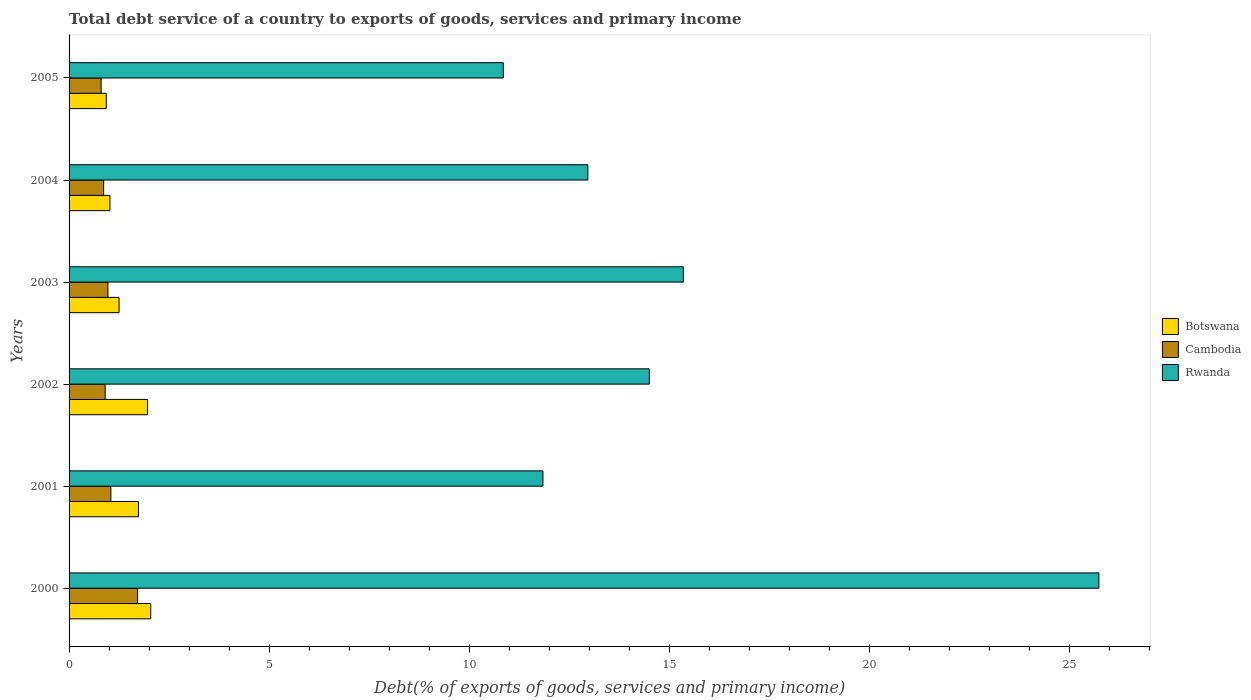How many different coloured bars are there?
Make the answer very short. 3. How many bars are there on the 2nd tick from the top?
Your response must be concise. 3. How many bars are there on the 2nd tick from the bottom?
Give a very brief answer. 3. What is the label of the 2nd group of bars from the top?
Provide a short and direct response. 2004. In how many cases, is the number of bars for a given year not equal to the number of legend labels?
Provide a succinct answer. 0. What is the total debt service in Botswana in 2003?
Ensure brevity in your answer.  1.25. Across all years, what is the maximum total debt service in Rwanda?
Provide a short and direct response. 25.73. Across all years, what is the minimum total debt service in Botswana?
Keep it short and to the point. 0.93. What is the total total debt service in Rwanda in the graph?
Your answer should be very brief. 91.22. What is the difference between the total debt service in Rwanda in 2004 and that in 2005?
Your answer should be very brief. 2.11. What is the difference between the total debt service in Rwanda in 2004 and the total debt service in Botswana in 2001?
Make the answer very short. 11.23. What is the average total debt service in Rwanda per year?
Make the answer very short. 15.2. In the year 2002, what is the difference between the total debt service in Cambodia and total debt service in Botswana?
Provide a succinct answer. -1.06. What is the ratio of the total debt service in Cambodia in 2002 to that in 2005?
Give a very brief answer. 1.13. Is the total debt service in Cambodia in 2003 less than that in 2004?
Your answer should be very brief. No. Is the difference between the total debt service in Cambodia in 2000 and 2002 greater than the difference between the total debt service in Botswana in 2000 and 2002?
Provide a short and direct response. Yes. What is the difference between the highest and the second highest total debt service in Rwanda?
Your answer should be compact. 10.38. What is the difference between the highest and the lowest total debt service in Rwanda?
Your response must be concise. 14.88. What does the 2nd bar from the top in 2005 represents?
Make the answer very short. Cambodia. What does the 3rd bar from the bottom in 2004 represents?
Provide a short and direct response. Rwanda. Are the values on the major ticks of X-axis written in scientific E-notation?
Offer a very short reply. No. Does the graph contain any zero values?
Keep it short and to the point. No. Where does the legend appear in the graph?
Ensure brevity in your answer.  Center right. How are the legend labels stacked?
Provide a short and direct response. Vertical. What is the title of the graph?
Keep it short and to the point. Total debt service of a country to exports of goods, services and primary income. Does "Botswana" appear as one of the legend labels in the graph?
Your answer should be compact. Yes. What is the label or title of the X-axis?
Your answer should be very brief. Debt(% of exports of goods, services and primary income). What is the Debt(% of exports of goods, services and primary income) in Botswana in 2000?
Ensure brevity in your answer.  2.04. What is the Debt(% of exports of goods, services and primary income) in Cambodia in 2000?
Provide a succinct answer. 1.71. What is the Debt(% of exports of goods, services and primary income) of Rwanda in 2000?
Make the answer very short. 25.73. What is the Debt(% of exports of goods, services and primary income) of Botswana in 2001?
Make the answer very short. 1.73. What is the Debt(% of exports of goods, services and primary income) of Cambodia in 2001?
Offer a very short reply. 1.04. What is the Debt(% of exports of goods, services and primary income) of Rwanda in 2001?
Provide a short and direct response. 11.84. What is the Debt(% of exports of goods, services and primary income) of Botswana in 2002?
Your answer should be compact. 1.96. What is the Debt(% of exports of goods, services and primary income) in Cambodia in 2002?
Your answer should be very brief. 0.9. What is the Debt(% of exports of goods, services and primary income) of Rwanda in 2002?
Your answer should be very brief. 14.5. What is the Debt(% of exports of goods, services and primary income) in Botswana in 2003?
Make the answer very short. 1.25. What is the Debt(% of exports of goods, services and primary income) in Cambodia in 2003?
Keep it short and to the point. 0.97. What is the Debt(% of exports of goods, services and primary income) of Rwanda in 2003?
Keep it short and to the point. 15.35. What is the Debt(% of exports of goods, services and primary income) of Botswana in 2004?
Give a very brief answer. 1.02. What is the Debt(% of exports of goods, services and primary income) of Cambodia in 2004?
Keep it short and to the point. 0.86. What is the Debt(% of exports of goods, services and primary income) of Rwanda in 2004?
Your answer should be very brief. 12.96. What is the Debt(% of exports of goods, services and primary income) in Botswana in 2005?
Ensure brevity in your answer.  0.93. What is the Debt(% of exports of goods, services and primary income) in Cambodia in 2005?
Keep it short and to the point. 0.8. What is the Debt(% of exports of goods, services and primary income) in Rwanda in 2005?
Offer a terse response. 10.85. Across all years, what is the maximum Debt(% of exports of goods, services and primary income) in Botswana?
Ensure brevity in your answer.  2.04. Across all years, what is the maximum Debt(% of exports of goods, services and primary income) of Cambodia?
Offer a very short reply. 1.71. Across all years, what is the maximum Debt(% of exports of goods, services and primary income) of Rwanda?
Your answer should be compact. 25.73. Across all years, what is the minimum Debt(% of exports of goods, services and primary income) of Botswana?
Offer a very short reply. 0.93. Across all years, what is the minimum Debt(% of exports of goods, services and primary income) of Cambodia?
Provide a short and direct response. 0.8. Across all years, what is the minimum Debt(% of exports of goods, services and primary income) of Rwanda?
Your response must be concise. 10.85. What is the total Debt(% of exports of goods, services and primary income) in Botswana in the graph?
Your answer should be compact. 8.94. What is the total Debt(% of exports of goods, services and primary income) of Cambodia in the graph?
Provide a succinct answer. 6.29. What is the total Debt(% of exports of goods, services and primary income) of Rwanda in the graph?
Provide a succinct answer. 91.22. What is the difference between the Debt(% of exports of goods, services and primary income) in Botswana in 2000 and that in 2001?
Your answer should be compact. 0.31. What is the difference between the Debt(% of exports of goods, services and primary income) in Cambodia in 2000 and that in 2001?
Make the answer very short. 0.67. What is the difference between the Debt(% of exports of goods, services and primary income) in Rwanda in 2000 and that in 2001?
Your response must be concise. 13.89. What is the difference between the Debt(% of exports of goods, services and primary income) in Botswana in 2000 and that in 2002?
Provide a short and direct response. 0.08. What is the difference between the Debt(% of exports of goods, services and primary income) in Cambodia in 2000 and that in 2002?
Ensure brevity in your answer.  0.81. What is the difference between the Debt(% of exports of goods, services and primary income) of Rwanda in 2000 and that in 2002?
Keep it short and to the point. 11.23. What is the difference between the Debt(% of exports of goods, services and primary income) of Botswana in 2000 and that in 2003?
Give a very brief answer. 0.79. What is the difference between the Debt(% of exports of goods, services and primary income) in Cambodia in 2000 and that in 2003?
Ensure brevity in your answer.  0.74. What is the difference between the Debt(% of exports of goods, services and primary income) of Rwanda in 2000 and that in 2003?
Provide a succinct answer. 10.38. What is the difference between the Debt(% of exports of goods, services and primary income) of Botswana in 2000 and that in 2004?
Give a very brief answer. 1.02. What is the difference between the Debt(% of exports of goods, services and primary income) of Cambodia in 2000 and that in 2004?
Your response must be concise. 0.85. What is the difference between the Debt(% of exports of goods, services and primary income) in Rwanda in 2000 and that in 2004?
Ensure brevity in your answer.  12.77. What is the difference between the Debt(% of exports of goods, services and primary income) of Botswana in 2000 and that in 2005?
Ensure brevity in your answer.  1.11. What is the difference between the Debt(% of exports of goods, services and primary income) of Cambodia in 2000 and that in 2005?
Offer a very short reply. 0.91. What is the difference between the Debt(% of exports of goods, services and primary income) of Rwanda in 2000 and that in 2005?
Make the answer very short. 14.88. What is the difference between the Debt(% of exports of goods, services and primary income) in Botswana in 2001 and that in 2002?
Provide a succinct answer. -0.23. What is the difference between the Debt(% of exports of goods, services and primary income) of Cambodia in 2001 and that in 2002?
Your answer should be very brief. 0.14. What is the difference between the Debt(% of exports of goods, services and primary income) of Rwanda in 2001 and that in 2002?
Ensure brevity in your answer.  -2.66. What is the difference between the Debt(% of exports of goods, services and primary income) of Botswana in 2001 and that in 2003?
Provide a succinct answer. 0.48. What is the difference between the Debt(% of exports of goods, services and primary income) of Cambodia in 2001 and that in 2003?
Provide a succinct answer. 0.07. What is the difference between the Debt(% of exports of goods, services and primary income) in Rwanda in 2001 and that in 2003?
Make the answer very short. -3.51. What is the difference between the Debt(% of exports of goods, services and primary income) of Botswana in 2001 and that in 2004?
Provide a short and direct response. 0.71. What is the difference between the Debt(% of exports of goods, services and primary income) of Cambodia in 2001 and that in 2004?
Provide a short and direct response. 0.18. What is the difference between the Debt(% of exports of goods, services and primary income) of Rwanda in 2001 and that in 2004?
Give a very brief answer. -1.12. What is the difference between the Debt(% of exports of goods, services and primary income) in Botswana in 2001 and that in 2005?
Offer a very short reply. 0.8. What is the difference between the Debt(% of exports of goods, services and primary income) in Cambodia in 2001 and that in 2005?
Offer a terse response. 0.24. What is the difference between the Debt(% of exports of goods, services and primary income) of Botswana in 2002 and that in 2003?
Offer a terse response. 0.71. What is the difference between the Debt(% of exports of goods, services and primary income) in Cambodia in 2002 and that in 2003?
Offer a very short reply. -0.07. What is the difference between the Debt(% of exports of goods, services and primary income) in Rwanda in 2002 and that in 2003?
Offer a very short reply. -0.85. What is the difference between the Debt(% of exports of goods, services and primary income) of Botswana in 2002 and that in 2004?
Provide a short and direct response. 0.94. What is the difference between the Debt(% of exports of goods, services and primary income) in Cambodia in 2002 and that in 2004?
Your answer should be compact. 0.04. What is the difference between the Debt(% of exports of goods, services and primary income) in Rwanda in 2002 and that in 2004?
Provide a succinct answer. 1.54. What is the difference between the Debt(% of exports of goods, services and primary income) in Botswana in 2002 and that in 2005?
Provide a short and direct response. 1.03. What is the difference between the Debt(% of exports of goods, services and primary income) in Cambodia in 2002 and that in 2005?
Offer a very short reply. 0.1. What is the difference between the Debt(% of exports of goods, services and primary income) in Rwanda in 2002 and that in 2005?
Offer a terse response. 3.65. What is the difference between the Debt(% of exports of goods, services and primary income) of Botswana in 2003 and that in 2004?
Provide a succinct answer. 0.23. What is the difference between the Debt(% of exports of goods, services and primary income) of Cambodia in 2003 and that in 2004?
Provide a short and direct response. 0.11. What is the difference between the Debt(% of exports of goods, services and primary income) of Rwanda in 2003 and that in 2004?
Your answer should be very brief. 2.38. What is the difference between the Debt(% of exports of goods, services and primary income) of Botswana in 2003 and that in 2005?
Make the answer very short. 0.32. What is the difference between the Debt(% of exports of goods, services and primary income) in Cambodia in 2003 and that in 2005?
Your response must be concise. 0.17. What is the difference between the Debt(% of exports of goods, services and primary income) of Rwanda in 2003 and that in 2005?
Your answer should be compact. 4.5. What is the difference between the Debt(% of exports of goods, services and primary income) of Botswana in 2004 and that in 2005?
Your answer should be compact. 0.09. What is the difference between the Debt(% of exports of goods, services and primary income) in Cambodia in 2004 and that in 2005?
Offer a very short reply. 0.06. What is the difference between the Debt(% of exports of goods, services and primary income) of Rwanda in 2004 and that in 2005?
Offer a terse response. 2.11. What is the difference between the Debt(% of exports of goods, services and primary income) in Botswana in 2000 and the Debt(% of exports of goods, services and primary income) in Cambodia in 2001?
Make the answer very short. 1. What is the difference between the Debt(% of exports of goods, services and primary income) in Botswana in 2000 and the Debt(% of exports of goods, services and primary income) in Rwanda in 2001?
Provide a succinct answer. -9.8. What is the difference between the Debt(% of exports of goods, services and primary income) in Cambodia in 2000 and the Debt(% of exports of goods, services and primary income) in Rwanda in 2001?
Your answer should be very brief. -10.13. What is the difference between the Debt(% of exports of goods, services and primary income) in Botswana in 2000 and the Debt(% of exports of goods, services and primary income) in Cambodia in 2002?
Provide a succinct answer. 1.14. What is the difference between the Debt(% of exports of goods, services and primary income) in Botswana in 2000 and the Debt(% of exports of goods, services and primary income) in Rwanda in 2002?
Provide a succinct answer. -12.46. What is the difference between the Debt(% of exports of goods, services and primary income) in Cambodia in 2000 and the Debt(% of exports of goods, services and primary income) in Rwanda in 2002?
Give a very brief answer. -12.79. What is the difference between the Debt(% of exports of goods, services and primary income) of Botswana in 2000 and the Debt(% of exports of goods, services and primary income) of Cambodia in 2003?
Offer a very short reply. 1.07. What is the difference between the Debt(% of exports of goods, services and primary income) in Botswana in 2000 and the Debt(% of exports of goods, services and primary income) in Rwanda in 2003?
Your answer should be compact. -13.31. What is the difference between the Debt(% of exports of goods, services and primary income) in Cambodia in 2000 and the Debt(% of exports of goods, services and primary income) in Rwanda in 2003?
Keep it short and to the point. -13.63. What is the difference between the Debt(% of exports of goods, services and primary income) in Botswana in 2000 and the Debt(% of exports of goods, services and primary income) in Cambodia in 2004?
Make the answer very short. 1.18. What is the difference between the Debt(% of exports of goods, services and primary income) in Botswana in 2000 and the Debt(% of exports of goods, services and primary income) in Rwanda in 2004?
Keep it short and to the point. -10.92. What is the difference between the Debt(% of exports of goods, services and primary income) of Cambodia in 2000 and the Debt(% of exports of goods, services and primary income) of Rwanda in 2004?
Your response must be concise. -11.25. What is the difference between the Debt(% of exports of goods, services and primary income) of Botswana in 2000 and the Debt(% of exports of goods, services and primary income) of Cambodia in 2005?
Your answer should be compact. 1.24. What is the difference between the Debt(% of exports of goods, services and primary income) of Botswana in 2000 and the Debt(% of exports of goods, services and primary income) of Rwanda in 2005?
Offer a very short reply. -8.81. What is the difference between the Debt(% of exports of goods, services and primary income) of Cambodia in 2000 and the Debt(% of exports of goods, services and primary income) of Rwanda in 2005?
Ensure brevity in your answer.  -9.14. What is the difference between the Debt(% of exports of goods, services and primary income) in Botswana in 2001 and the Debt(% of exports of goods, services and primary income) in Cambodia in 2002?
Provide a short and direct response. 0.83. What is the difference between the Debt(% of exports of goods, services and primary income) in Botswana in 2001 and the Debt(% of exports of goods, services and primary income) in Rwanda in 2002?
Your response must be concise. -12.76. What is the difference between the Debt(% of exports of goods, services and primary income) of Cambodia in 2001 and the Debt(% of exports of goods, services and primary income) of Rwanda in 2002?
Your response must be concise. -13.45. What is the difference between the Debt(% of exports of goods, services and primary income) of Botswana in 2001 and the Debt(% of exports of goods, services and primary income) of Cambodia in 2003?
Keep it short and to the point. 0.76. What is the difference between the Debt(% of exports of goods, services and primary income) of Botswana in 2001 and the Debt(% of exports of goods, services and primary income) of Rwanda in 2003?
Provide a succinct answer. -13.61. What is the difference between the Debt(% of exports of goods, services and primary income) in Cambodia in 2001 and the Debt(% of exports of goods, services and primary income) in Rwanda in 2003?
Provide a succinct answer. -14.3. What is the difference between the Debt(% of exports of goods, services and primary income) in Botswana in 2001 and the Debt(% of exports of goods, services and primary income) in Cambodia in 2004?
Make the answer very short. 0.87. What is the difference between the Debt(% of exports of goods, services and primary income) of Botswana in 2001 and the Debt(% of exports of goods, services and primary income) of Rwanda in 2004?
Provide a short and direct response. -11.23. What is the difference between the Debt(% of exports of goods, services and primary income) of Cambodia in 2001 and the Debt(% of exports of goods, services and primary income) of Rwanda in 2004?
Give a very brief answer. -11.92. What is the difference between the Debt(% of exports of goods, services and primary income) of Botswana in 2001 and the Debt(% of exports of goods, services and primary income) of Cambodia in 2005?
Provide a succinct answer. 0.93. What is the difference between the Debt(% of exports of goods, services and primary income) of Botswana in 2001 and the Debt(% of exports of goods, services and primary income) of Rwanda in 2005?
Offer a very short reply. -9.12. What is the difference between the Debt(% of exports of goods, services and primary income) of Cambodia in 2001 and the Debt(% of exports of goods, services and primary income) of Rwanda in 2005?
Your answer should be very brief. -9.8. What is the difference between the Debt(% of exports of goods, services and primary income) in Botswana in 2002 and the Debt(% of exports of goods, services and primary income) in Cambodia in 2003?
Your response must be concise. 0.99. What is the difference between the Debt(% of exports of goods, services and primary income) of Botswana in 2002 and the Debt(% of exports of goods, services and primary income) of Rwanda in 2003?
Offer a terse response. -13.38. What is the difference between the Debt(% of exports of goods, services and primary income) in Cambodia in 2002 and the Debt(% of exports of goods, services and primary income) in Rwanda in 2003?
Your answer should be compact. -14.44. What is the difference between the Debt(% of exports of goods, services and primary income) of Botswana in 2002 and the Debt(% of exports of goods, services and primary income) of Cambodia in 2004?
Your answer should be compact. 1.1. What is the difference between the Debt(% of exports of goods, services and primary income) in Botswana in 2002 and the Debt(% of exports of goods, services and primary income) in Rwanda in 2004?
Your answer should be very brief. -11. What is the difference between the Debt(% of exports of goods, services and primary income) of Cambodia in 2002 and the Debt(% of exports of goods, services and primary income) of Rwanda in 2004?
Offer a terse response. -12.06. What is the difference between the Debt(% of exports of goods, services and primary income) of Botswana in 2002 and the Debt(% of exports of goods, services and primary income) of Cambodia in 2005?
Give a very brief answer. 1.16. What is the difference between the Debt(% of exports of goods, services and primary income) in Botswana in 2002 and the Debt(% of exports of goods, services and primary income) in Rwanda in 2005?
Give a very brief answer. -8.89. What is the difference between the Debt(% of exports of goods, services and primary income) of Cambodia in 2002 and the Debt(% of exports of goods, services and primary income) of Rwanda in 2005?
Your answer should be very brief. -9.95. What is the difference between the Debt(% of exports of goods, services and primary income) of Botswana in 2003 and the Debt(% of exports of goods, services and primary income) of Cambodia in 2004?
Your response must be concise. 0.39. What is the difference between the Debt(% of exports of goods, services and primary income) in Botswana in 2003 and the Debt(% of exports of goods, services and primary income) in Rwanda in 2004?
Keep it short and to the point. -11.71. What is the difference between the Debt(% of exports of goods, services and primary income) of Cambodia in 2003 and the Debt(% of exports of goods, services and primary income) of Rwanda in 2004?
Offer a terse response. -11.99. What is the difference between the Debt(% of exports of goods, services and primary income) in Botswana in 2003 and the Debt(% of exports of goods, services and primary income) in Cambodia in 2005?
Give a very brief answer. 0.45. What is the difference between the Debt(% of exports of goods, services and primary income) in Botswana in 2003 and the Debt(% of exports of goods, services and primary income) in Rwanda in 2005?
Offer a terse response. -9.6. What is the difference between the Debt(% of exports of goods, services and primary income) of Cambodia in 2003 and the Debt(% of exports of goods, services and primary income) of Rwanda in 2005?
Ensure brevity in your answer.  -9.88. What is the difference between the Debt(% of exports of goods, services and primary income) of Botswana in 2004 and the Debt(% of exports of goods, services and primary income) of Cambodia in 2005?
Your response must be concise. 0.22. What is the difference between the Debt(% of exports of goods, services and primary income) of Botswana in 2004 and the Debt(% of exports of goods, services and primary income) of Rwanda in 2005?
Provide a succinct answer. -9.83. What is the difference between the Debt(% of exports of goods, services and primary income) of Cambodia in 2004 and the Debt(% of exports of goods, services and primary income) of Rwanda in 2005?
Your response must be concise. -9.99. What is the average Debt(% of exports of goods, services and primary income) in Botswana per year?
Provide a succinct answer. 1.49. What is the average Debt(% of exports of goods, services and primary income) in Cambodia per year?
Your response must be concise. 1.05. What is the average Debt(% of exports of goods, services and primary income) in Rwanda per year?
Your answer should be very brief. 15.2. In the year 2000, what is the difference between the Debt(% of exports of goods, services and primary income) of Botswana and Debt(% of exports of goods, services and primary income) of Cambodia?
Your answer should be compact. 0.33. In the year 2000, what is the difference between the Debt(% of exports of goods, services and primary income) in Botswana and Debt(% of exports of goods, services and primary income) in Rwanda?
Provide a short and direct response. -23.69. In the year 2000, what is the difference between the Debt(% of exports of goods, services and primary income) in Cambodia and Debt(% of exports of goods, services and primary income) in Rwanda?
Ensure brevity in your answer.  -24.02. In the year 2001, what is the difference between the Debt(% of exports of goods, services and primary income) in Botswana and Debt(% of exports of goods, services and primary income) in Cambodia?
Offer a very short reply. 0.69. In the year 2001, what is the difference between the Debt(% of exports of goods, services and primary income) of Botswana and Debt(% of exports of goods, services and primary income) of Rwanda?
Your answer should be compact. -10.11. In the year 2001, what is the difference between the Debt(% of exports of goods, services and primary income) of Cambodia and Debt(% of exports of goods, services and primary income) of Rwanda?
Your answer should be very brief. -10.79. In the year 2002, what is the difference between the Debt(% of exports of goods, services and primary income) in Botswana and Debt(% of exports of goods, services and primary income) in Cambodia?
Offer a terse response. 1.06. In the year 2002, what is the difference between the Debt(% of exports of goods, services and primary income) of Botswana and Debt(% of exports of goods, services and primary income) of Rwanda?
Provide a short and direct response. -12.54. In the year 2002, what is the difference between the Debt(% of exports of goods, services and primary income) of Cambodia and Debt(% of exports of goods, services and primary income) of Rwanda?
Offer a very short reply. -13.6. In the year 2003, what is the difference between the Debt(% of exports of goods, services and primary income) of Botswana and Debt(% of exports of goods, services and primary income) of Cambodia?
Provide a short and direct response. 0.28. In the year 2003, what is the difference between the Debt(% of exports of goods, services and primary income) in Botswana and Debt(% of exports of goods, services and primary income) in Rwanda?
Ensure brevity in your answer.  -14.1. In the year 2003, what is the difference between the Debt(% of exports of goods, services and primary income) in Cambodia and Debt(% of exports of goods, services and primary income) in Rwanda?
Provide a short and direct response. -14.37. In the year 2004, what is the difference between the Debt(% of exports of goods, services and primary income) of Botswana and Debt(% of exports of goods, services and primary income) of Cambodia?
Ensure brevity in your answer.  0.16. In the year 2004, what is the difference between the Debt(% of exports of goods, services and primary income) in Botswana and Debt(% of exports of goods, services and primary income) in Rwanda?
Your answer should be compact. -11.94. In the year 2004, what is the difference between the Debt(% of exports of goods, services and primary income) of Cambodia and Debt(% of exports of goods, services and primary income) of Rwanda?
Keep it short and to the point. -12.1. In the year 2005, what is the difference between the Debt(% of exports of goods, services and primary income) of Botswana and Debt(% of exports of goods, services and primary income) of Cambodia?
Keep it short and to the point. 0.13. In the year 2005, what is the difference between the Debt(% of exports of goods, services and primary income) of Botswana and Debt(% of exports of goods, services and primary income) of Rwanda?
Ensure brevity in your answer.  -9.92. In the year 2005, what is the difference between the Debt(% of exports of goods, services and primary income) in Cambodia and Debt(% of exports of goods, services and primary income) in Rwanda?
Keep it short and to the point. -10.05. What is the ratio of the Debt(% of exports of goods, services and primary income) in Botswana in 2000 to that in 2001?
Your answer should be very brief. 1.18. What is the ratio of the Debt(% of exports of goods, services and primary income) of Cambodia in 2000 to that in 2001?
Make the answer very short. 1.64. What is the ratio of the Debt(% of exports of goods, services and primary income) of Rwanda in 2000 to that in 2001?
Provide a short and direct response. 2.17. What is the ratio of the Debt(% of exports of goods, services and primary income) of Botswana in 2000 to that in 2002?
Provide a short and direct response. 1.04. What is the ratio of the Debt(% of exports of goods, services and primary income) in Cambodia in 2000 to that in 2002?
Keep it short and to the point. 1.9. What is the ratio of the Debt(% of exports of goods, services and primary income) in Rwanda in 2000 to that in 2002?
Make the answer very short. 1.77. What is the ratio of the Debt(% of exports of goods, services and primary income) in Botswana in 2000 to that in 2003?
Offer a terse response. 1.63. What is the ratio of the Debt(% of exports of goods, services and primary income) of Cambodia in 2000 to that in 2003?
Your answer should be very brief. 1.76. What is the ratio of the Debt(% of exports of goods, services and primary income) of Rwanda in 2000 to that in 2003?
Keep it short and to the point. 1.68. What is the ratio of the Debt(% of exports of goods, services and primary income) in Botswana in 2000 to that in 2004?
Your response must be concise. 2. What is the ratio of the Debt(% of exports of goods, services and primary income) in Cambodia in 2000 to that in 2004?
Your answer should be compact. 1.98. What is the ratio of the Debt(% of exports of goods, services and primary income) of Rwanda in 2000 to that in 2004?
Offer a very short reply. 1.99. What is the ratio of the Debt(% of exports of goods, services and primary income) in Botswana in 2000 to that in 2005?
Provide a short and direct response. 2.19. What is the ratio of the Debt(% of exports of goods, services and primary income) in Cambodia in 2000 to that in 2005?
Your response must be concise. 2.14. What is the ratio of the Debt(% of exports of goods, services and primary income) of Rwanda in 2000 to that in 2005?
Provide a short and direct response. 2.37. What is the ratio of the Debt(% of exports of goods, services and primary income) in Botswana in 2001 to that in 2002?
Your answer should be compact. 0.88. What is the ratio of the Debt(% of exports of goods, services and primary income) in Cambodia in 2001 to that in 2002?
Your answer should be compact. 1.16. What is the ratio of the Debt(% of exports of goods, services and primary income) of Rwanda in 2001 to that in 2002?
Make the answer very short. 0.82. What is the ratio of the Debt(% of exports of goods, services and primary income) in Botswana in 2001 to that in 2003?
Offer a very short reply. 1.39. What is the ratio of the Debt(% of exports of goods, services and primary income) of Cambodia in 2001 to that in 2003?
Your response must be concise. 1.08. What is the ratio of the Debt(% of exports of goods, services and primary income) of Rwanda in 2001 to that in 2003?
Your answer should be compact. 0.77. What is the ratio of the Debt(% of exports of goods, services and primary income) of Botswana in 2001 to that in 2004?
Provide a short and direct response. 1.7. What is the ratio of the Debt(% of exports of goods, services and primary income) in Cambodia in 2001 to that in 2004?
Keep it short and to the point. 1.21. What is the ratio of the Debt(% of exports of goods, services and primary income) of Rwanda in 2001 to that in 2004?
Keep it short and to the point. 0.91. What is the ratio of the Debt(% of exports of goods, services and primary income) of Botswana in 2001 to that in 2005?
Offer a terse response. 1.86. What is the ratio of the Debt(% of exports of goods, services and primary income) of Cambodia in 2001 to that in 2005?
Ensure brevity in your answer.  1.3. What is the ratio of the Debt(% of exports of goods, services and primary income) in Rwanda in 2001 to that in 2005?
Offer a terse response. 1.09. What is the ratio of the Debt(% of exports of goods, services and primary income) in Botswana in 2002 to that in 2003?
Offer a terse response. 1.57. What is the ratio of the Debt(% of exports of goods, services and primary income) in Cambodia in 2002 to that in 2003?
Provide a short and direct response. 0.93. What is the ratio of the Debt(% of exports of goods, services and primary income) in Rwanda in 2002 to that in 2003?
Give a very brief answer. 0.94. What is the ratio of the Debt(% of exports of goods, services and primary income) of Botswana in 2002 to that in 2004?
Give a very brief answer. 1.92. What is the ratio of the Debt(% of exports of goods, services and primary income) in Cambodia in 2002 to that in 2004?
Make the answer very short. 1.04. What is the ratio of the Debt(% of exports of goods, services and primary income) of Rwanda in 2002 to that in 2004?
Your answer should be very brief. 1.12. What is the ratio of the Debt(% of exports of goods, services and primary income) in Botswana in 2002 to that in 2005?
Your answer should be very brief. 2.11. What is the ratio of the Debt(% of exports of goods, services and primary income) in Cambodia in 2002 to that in 2005?
Offer a very short reply. 1.13. What is the ratio of the Debt(% of exports of goods, services and primary income) in Rwanda in 2002 to that in 2005?
Your answer should be very brief. 1.34. What is the ratio of the Debt(% of exports of goods, services and primary income) of Botswana in 2003 to that in 2004?
Provide a short and direct response. 1.22. What is the ratio of the Debt(% of exports of goods, services and primary income) in Cambodia in 2003 to that in 2004?
Provide a succinct answer. 1.12. What is the ratio of the Debt(% of exports of goods, services and primary income) in Rwanda in 2003 to that in 2004?
Offer a very short reply. 1.18. What is the ratio of the Debt(% of exports of goods, services and primary income) of Botswana in 2003 to that in 2005?
Keep it short and to the point. 1.34. What is the ratio of the Debt(% of exports of goods, services and primary income) in Cambodia in 2003 to that in 2005?
Provide a short and direct response. 1.21. What is the ratio of the Debt(% of exports of goods, services and primary income) in Rwanda in 2003 to that in 2005?
Ensure brevity in your answer.  1.41. What is the ratio of the Debt(% of exports of goods, services and primary income) in Botswana in 2004 to that in 2005?
Give a very brief answer. 1.1. What is the ratio of the Debt(% of exports of goods, services and primary income) of Cambodia in 2004 to that in 2005?
Give a very brief answer. 1.08. What is the ratio of the Debt(% of exports of goods, services and primary income) in Rwanda in 2004 to that in 2005?
Provide a short and direct response. 1.19. What is the difference between the highest and the second highest Debt(% of exports of goods, services and primary income) in Botswana?
Offer a terse response. 0.08. What is the difference between the highest and the second highest Debt(% of exports of goods, services and primary income) in Cambodia?
Your response must be concise. 0.67. What is the difference between the highest and the second highest Debt(% of exports of goods, services and primary income) in Rwanda?
Provide a short and direct response. 10.38. What is the difference between the highest and the lowest Debt(% of exports of goods, services and primary income) of Botswana?
Ensure brevity in your answer.  1.11. What is the difference between the highest and the lowest Debt(% of exports of goods, services and primary income) in Cambodia?
Give a very brief answer. 0.91. What is the difference between the highest and the lowest Debt(% of exports of goods, services and primary income) of Rwanda?
Your answer should be very brief. 14.88. 